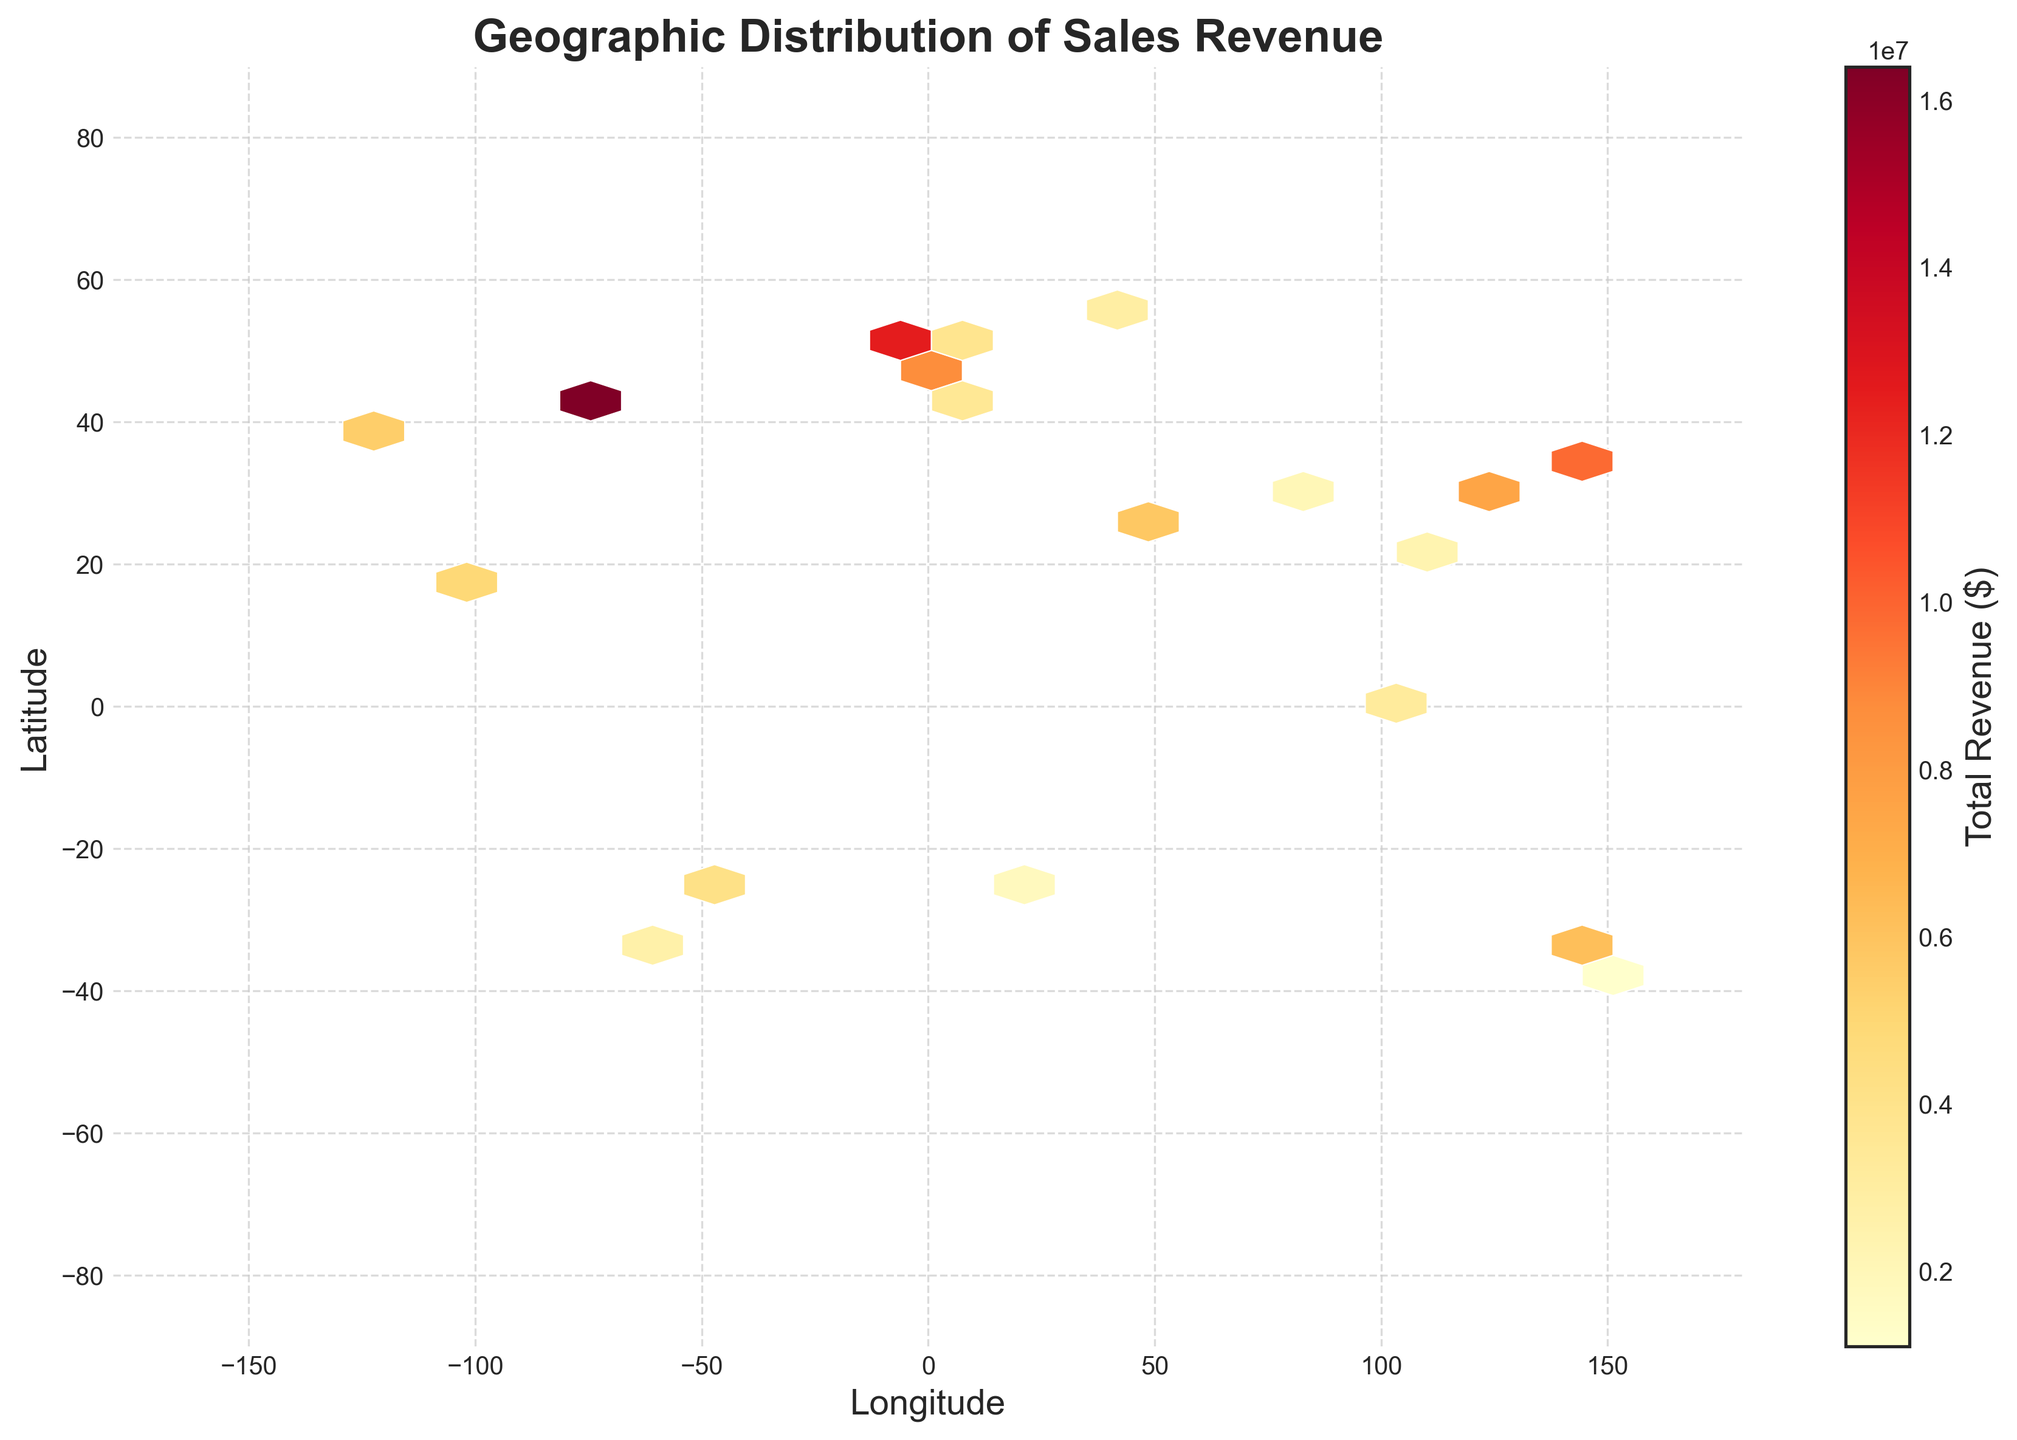What is the title of the plot? Look at the top of the plot where the title is usually displayed. The title reads "Geographic Distribution of Sales Revenue".
Answer: Geographic Distribution of Sales Revenue How is revenue represented in the hexbin plot? Revenue is represented by color intensity in the hexagons. The color bar on the right of the plot indicates total revenue in dollars, with darker colors corresponding to higher revenues.
Answer: By color intensity What are the axes labeled as? Check the labels on the horizontal and vertical axes. The horizontal axis is labeled "Longitude" and the vertical axis is labeled "Latitude".
Answer: Longitude (horizontal) and Latitude (vertical) Which region has the highest revenue concentration? Look for the region with the darkest hexagons, indicating the highest revenue. The darkest hexagons are around the coordinates of New York, near (40.7128, -74.0060).
Answer: Around New York Which regions show moderate revenue levels? Look for regions with hexagons that are neither the darkest nor the lightest. Moderate revenue levels are seen around London, Tokyo, and Paris.
Answer: London, Tokyo, Paris What is the color of hexagons with the lowest revenue levels? Check the color bar and identify the color representing the lowest value. The lightest color on the hexbin plot represents the lowest revenue levels.
Answer: The lightest color How does the revenue distribution differ between North America and Europe? Compare the hexagon colors in North America and Europe. North America (particularly around New York) shows darker hexagons, whereas Europe has spread-out moderate revenue in places like London and Paris.
Answer: Darker in North America, moderate in Europe Are there any regions with very low revenue concentration? Look for the sparsest or the lightest hexagons on the plot. Regions like Africa and South America have the lightest hexagons, indicating very low revenue.
Answer: Africa and South America Which axis has a wider revenue span: Longitude or Latitude? Compare the spread of the hexagons along both axes. Revenue spans a wider range of longitudes compared to latitudes.
Answer: Longitude Based on the plot, which city is likely contributing the least to total revenue? Identify the city coordinates corresponding to the lightest hexagons. The coordinates of Melbourne, (-37.8136, 144.9631), have the lightest hexagons, indicating the least revenue contribution.
Answer: Melbourne 